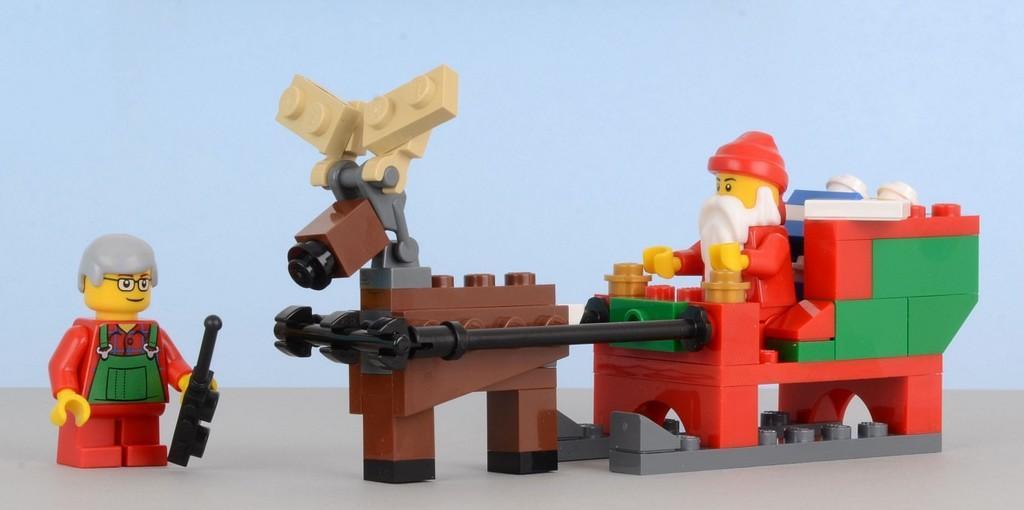Please provide a concise description of this image. In this image in the center there are some building blocks and toys, in the background there is a wall. 